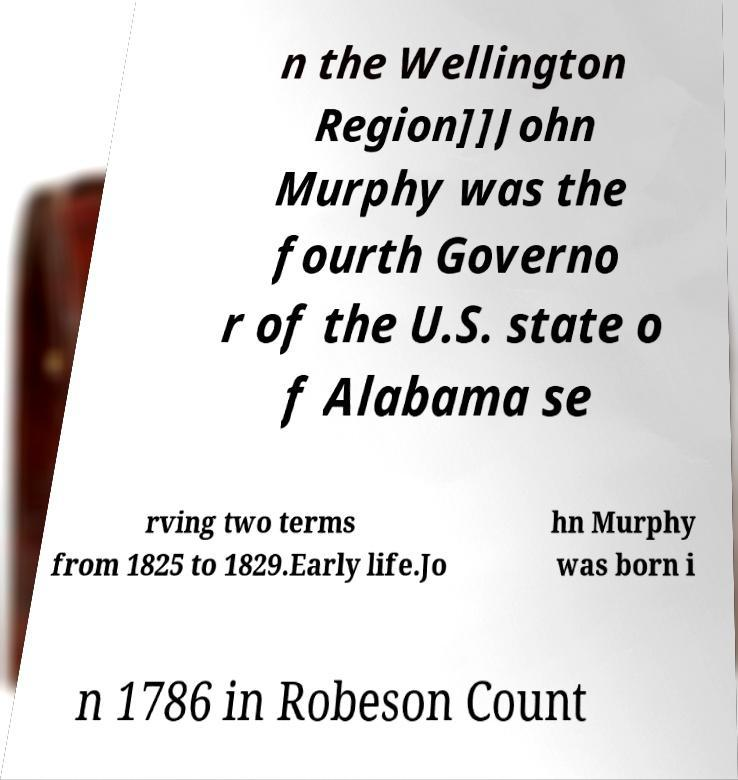What messages or text are displayed in this image? I need them in a readable, typed format. n the Wellington Region]]John Murphy was the fourth Governo r of the U.S. state o f Alabama se rving two terms from 1825 to 1829.Early life.Jo hn Murphy was born i n 1786 in Robeson Count 